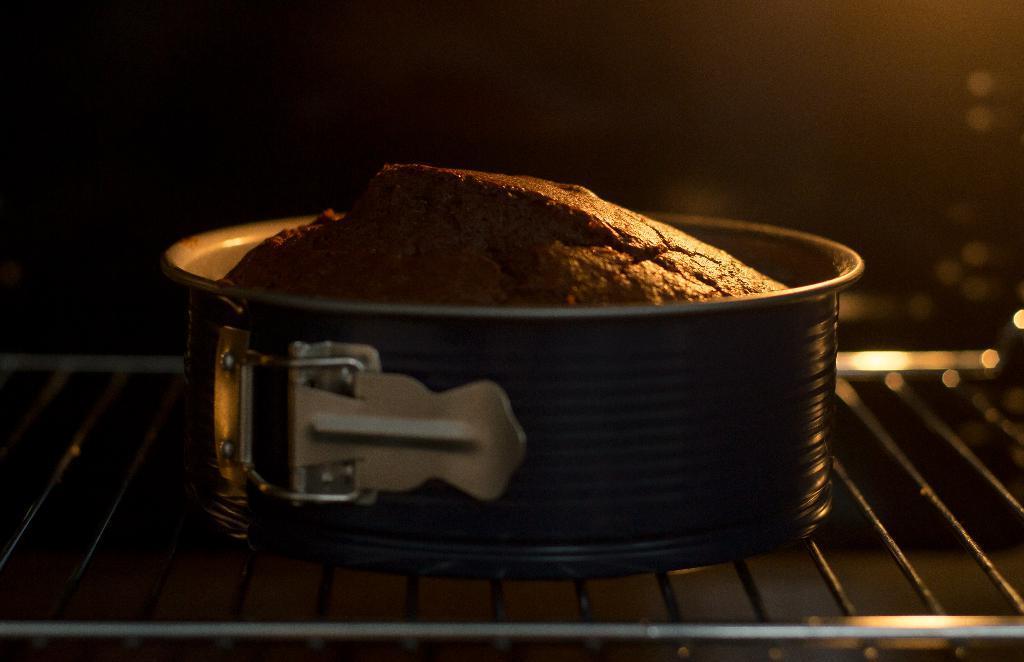Describe this image in one or two sentences. In this picture we can see brown baking cake in the steel bowl, placed on the grill. Behind there is a dark background. 